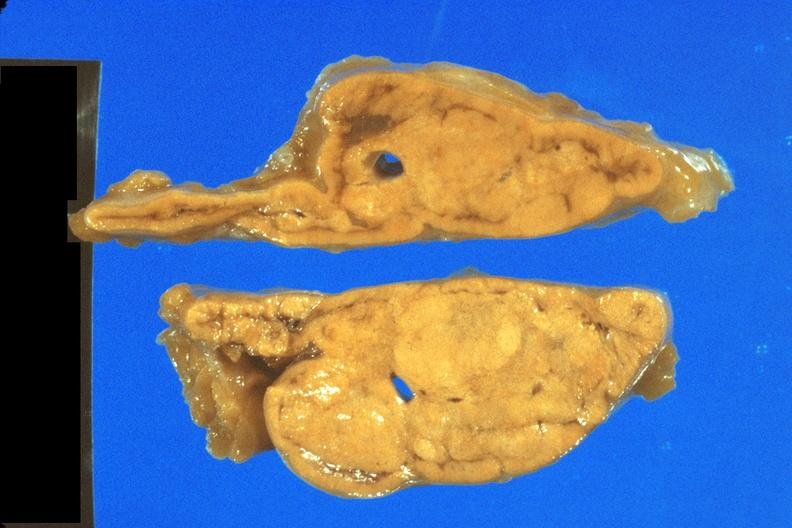what does this image show?
Answer the question using a single word or phrase. Fixed tissue nice close-up view of cortical nodules 